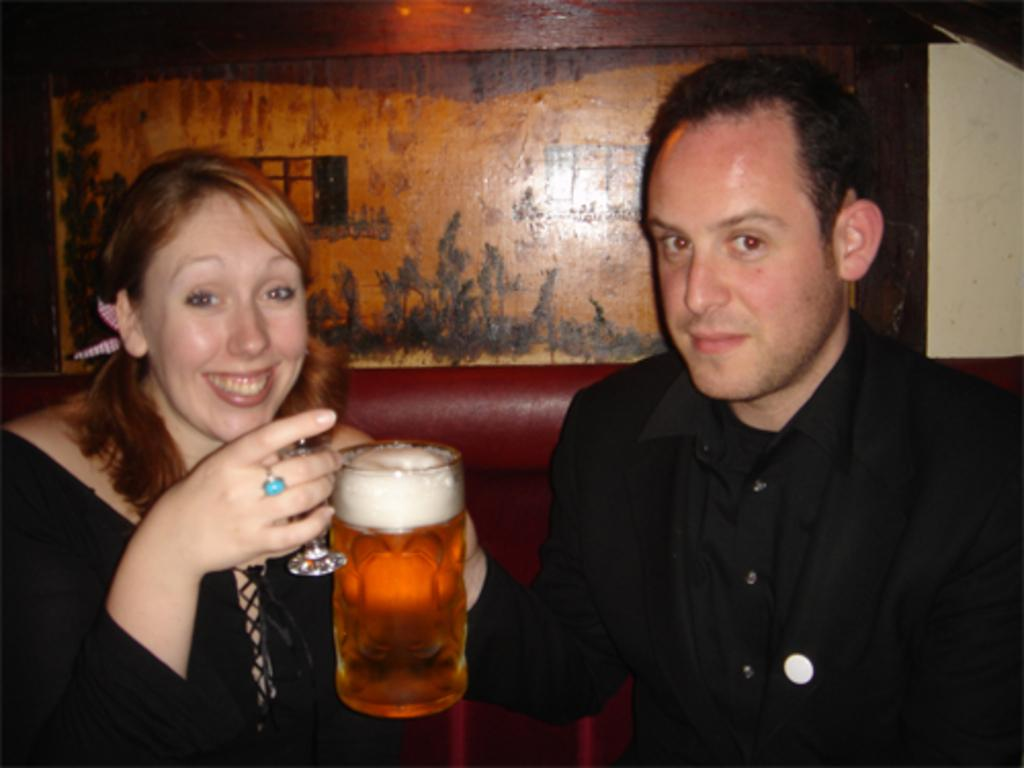How many people are present in the image? There are two persons sitting in the image. What are the persons holding in their hands? The persons are holding glasses. What is the facial expression of the persons in the image? The persons are smiling. What can be seen in the background of the image? There is a wall in the background of the image. Can you see any ants crawling on the persons in the image? There are no ants visible in the image. What type of map is hanging on the wall in the background? There is no map present in the image; only a wall is visible in the background. 